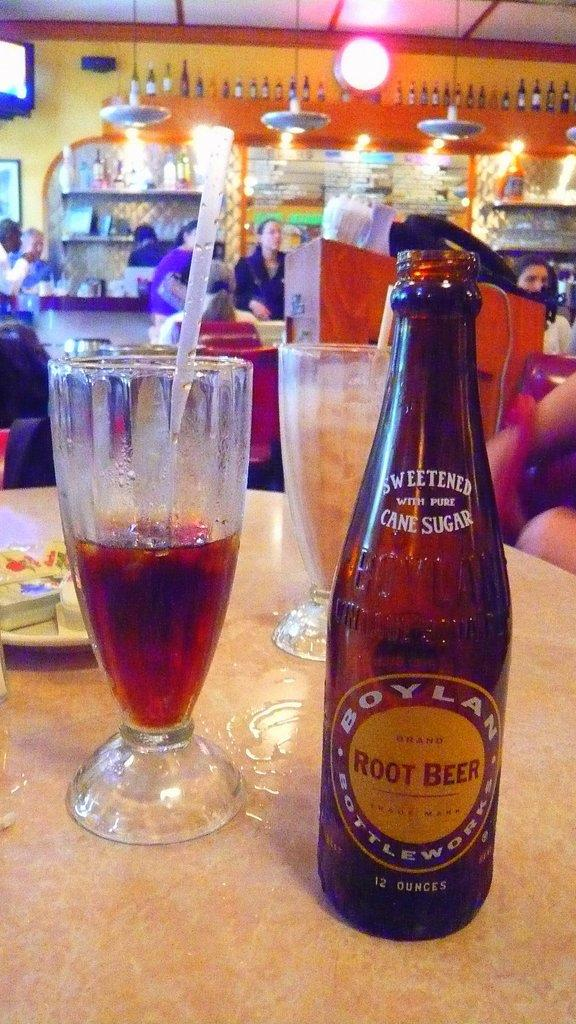<image>
Describe the image concisely. A bottle Boylan Root Beer on a table next two glasses of a half a glass of root beer with a straw in the glass. 